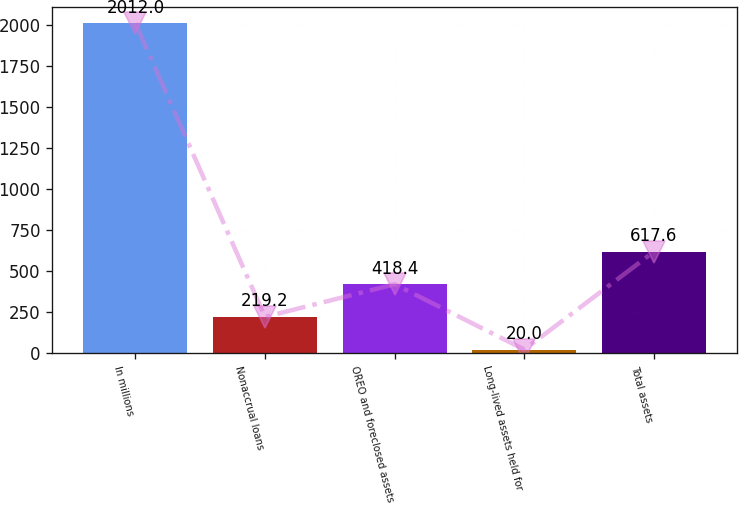<chart> <loc_0><loc_0><loc_500><loc_500><bar_chart><fcel>In millions<fcel>Nonaccrual loans<fcel>OREO and foreclosed assets<fcel>Long-lived assets held for<fcel>Total assets<nl><fcel>2012<fcel>219.2<fcel>418.4<fcel>20<fcel>617.6<nl></chart> 